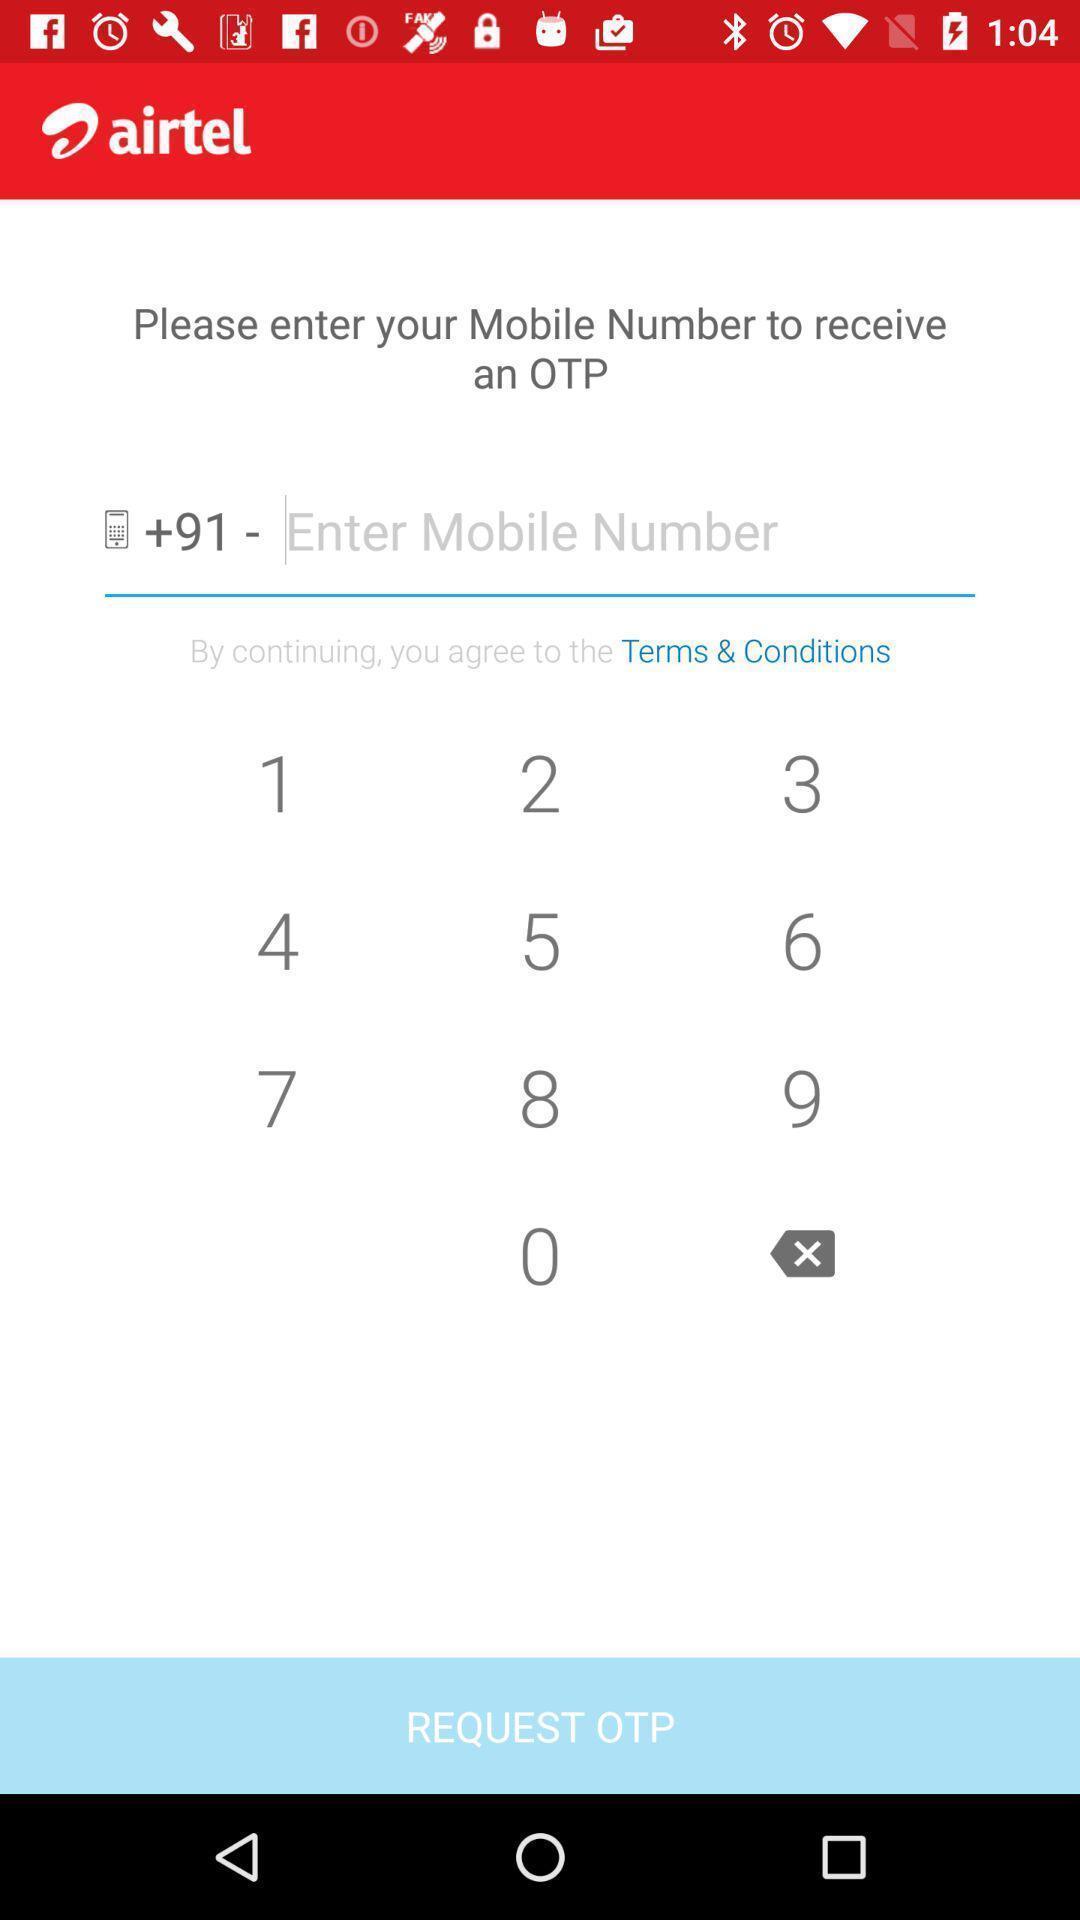Describe the key features of this screenshot. Page displaying data to be entered in mobile recharge application. 